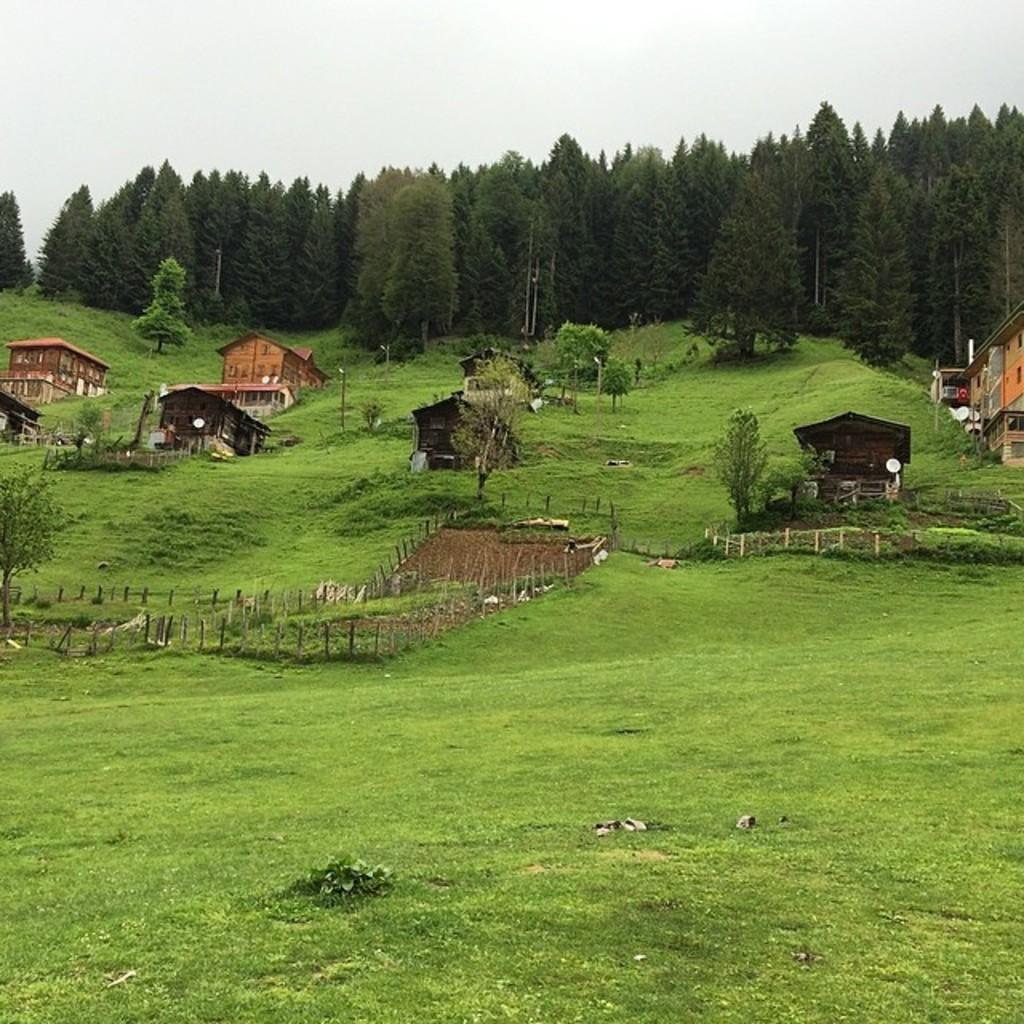Can you describe this image briefly? In this image I can see an open grass ground and in background I can see a number of trees and few buildings. I can also see few poles. 